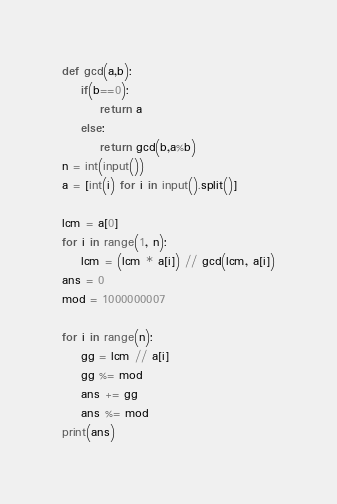Convert code to text. <code><loc_0><loc_0><loc_500><loc_500><_Python_>def gcd(a,b): 
    if(b==0): 
        return a 
    else: 
        return gcd(b,a%b) 
n = int(input())
a = [int(i) for i in input().split()]

lcm = a[0]
for i in range(1, n):
    lcm = (lcm * a[i]) // gcd(lcm, a[i])
ans = 0
mod = 1000000007

for i in range(n):
    gg = lcm // a[i]
    gg %= mod
    ans += gg
    ans %= mod
print(ans)
</code> 